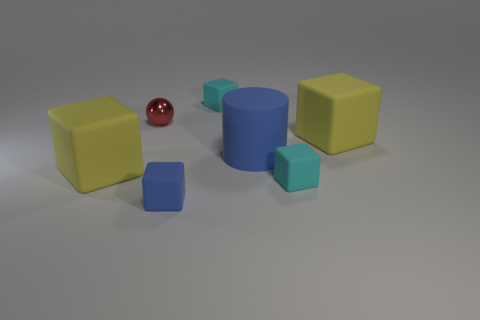Subtract 2 blocks. How many blocks are left? 3 Subtract all blue blocks. How many blocks are left? 4 Subtract all blue rubber blocks. How many blocks are left? 4 Subtract all brown cubes. Subtract all yellow cylinders. How many cubes are left? 5 Add 3 big cyan cylinders. How many objects exist? 10 Subtract all cylinders. How many objects are left? 6 Subtract 0 cyan cylinders. How many objects are left? 7 Subtract all large blue rubber things. Subtract all cyan rubber cubes. How many objects are left? 4 Add 1 blue objects. How many blue objects are left? 3 Add 5 cyan rubber blocks. How many cyan rubber blocks exist? 7 